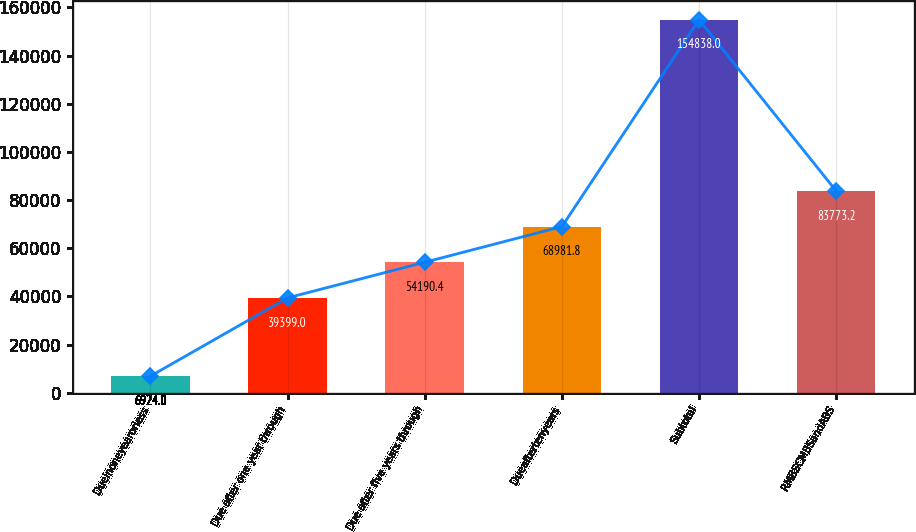Convert chart. <chart><loc_0><loc_0><loc_500><loc_500><bar_chart><fcel>Dueinoneyearorless<fcel>Due after one year through<fcel>Due after five years through<fcel>Dueaftertenyears<fcel>Subtotal<fcel>RMBSCMBSandABS<nl><fcel>6924<fcel>39399<fcel>54190.4<fcel>68981.8<fcel>154838<fcel>83773.2<nl></chart> 